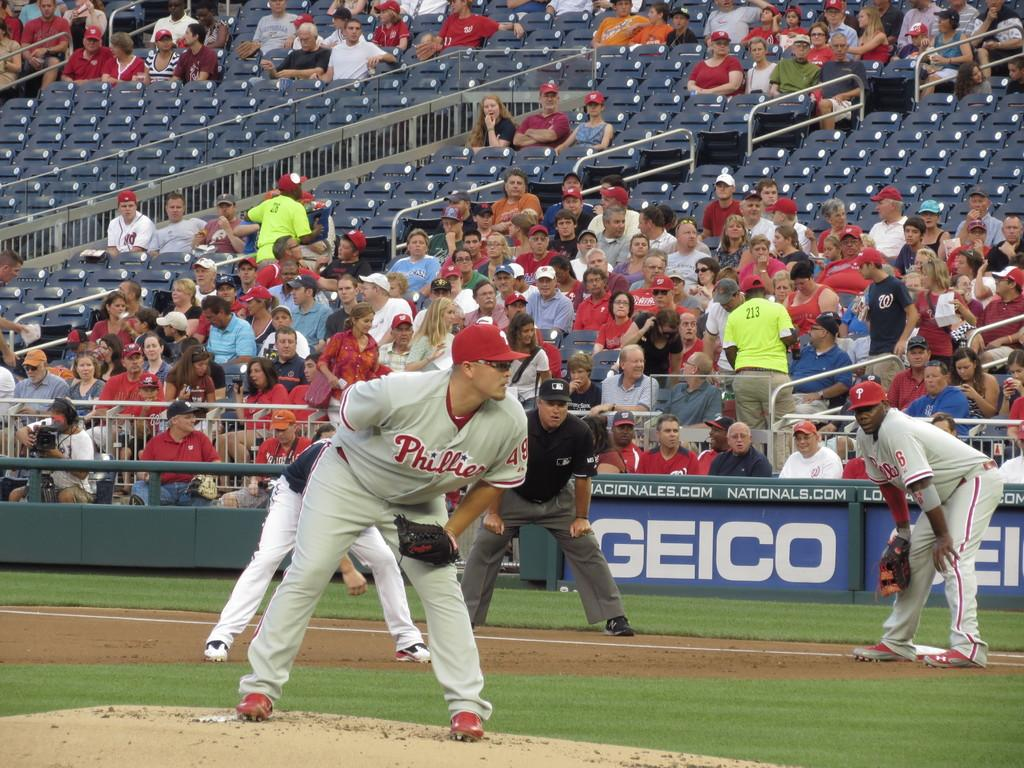<image>
Write a terse but informative summary of the picture. a Phillies player that is holding a baseball in their hand 